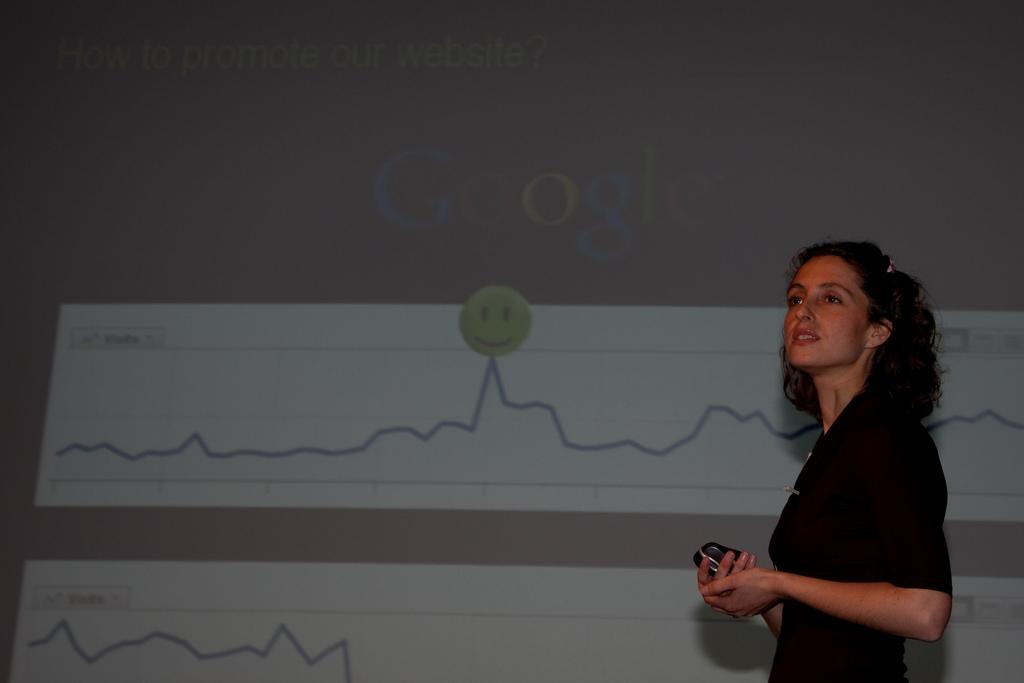Who is the main subject in the image? There is a woman in the image. What is the woman doing in the image? The woman is giving a seminar. What is the woman holding in her hands? The woman is holding a gadget in her hands. What can be seen behind the woman during the seminar? There is a seminar displaying pictures behind the woman. What type of star can be seen in the image? There is no star present in the image. Is the woman selling items at a market in the image? No, the woman is giving a seminar, not selling items at a market. 